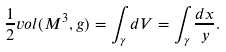Convert formula to latex. <formula><loc_0><loc_0><loc_500><loc_500>\frac { 1 } { 2 } v o l ( M ^ { 3 } , g ) = \int _ { \gamma } d V = \int _ { \gamma } \frac { d x } { y } .</formula> 